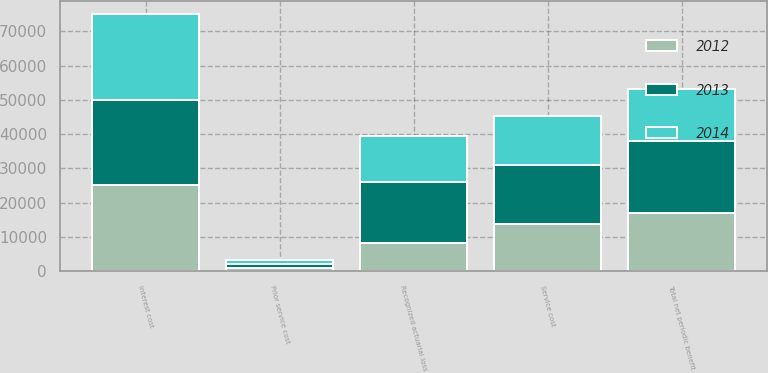Convert chart. <chart><loc_0><loc_0><loc_500><loc_500><stacked_bar_chart><ecel><fcel>Service cost<fcel>Interest cost<fcel>Prior service cost<fcel>Recognized actuarial loss<fcel>Total net periodic benefit<nl><fcel>2012<fcel>13801<fcel>25204<fcel>1083<fcel>8289<fcel>17062<nl><fcel>2013<fcel>17123<fcel>24801<fcel>1026<fcel>17654<fcel>21098<nl><fcel>2014<fcel>14406<fcel>25136<fcel>1048<fcel>13515<fcel>15127<nl></chart> 